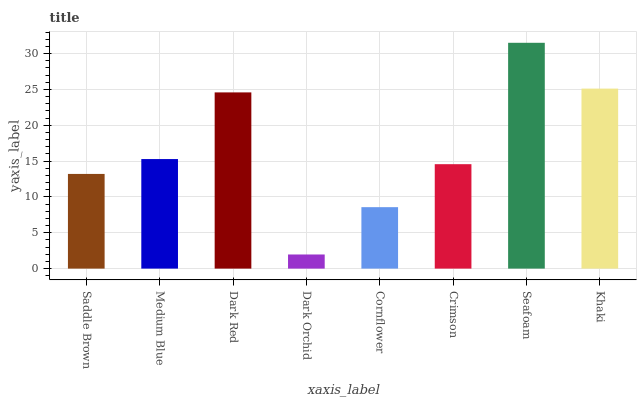Is Dark Orchid the minimum?
Answer yes or no. Yes. Is Seafoam the maximum?
Answer yes or no. Yes. Is Medium Blue the minimum?
Answer yes or no. No. Is Medium Blue the maximum?
Answer yes or no. No. Is Medium Blue greater than Saddle Brown?
Answer yes or no. Yes. Is Saddle Brown less than Medium Blue?
Answer yes or no. Yes. Is Saddle Brown greater than Medium Blue?
Answer yes or no. No. Is Medium Blue less than Saddle Brown?
Answer yes or no. No. Is Medium Blue the high median?
Answer yes or no. Yes. Is Crimson the low median?
Answer yes or no. Yes. Is Khaki the high median?
Answer yes or no. No. Is Dark Red the low median?
Answer yes or no. No. 